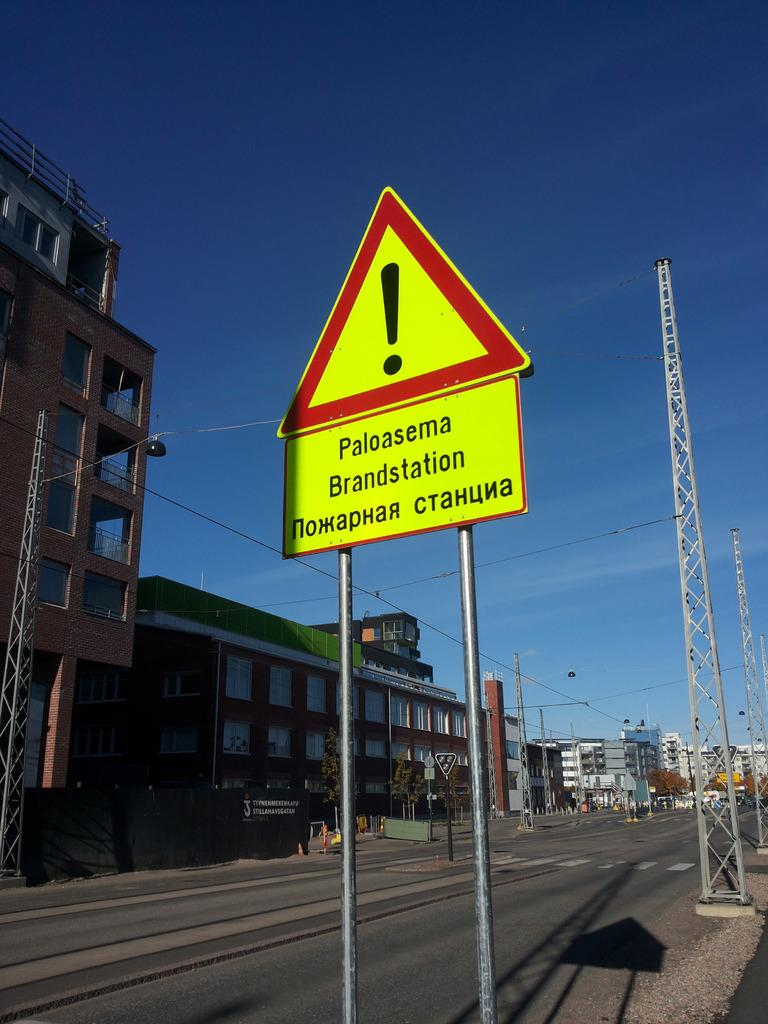<image>
Create a compact narrative representing the image presented. A caution sign on the road with a huge exclamation mark 